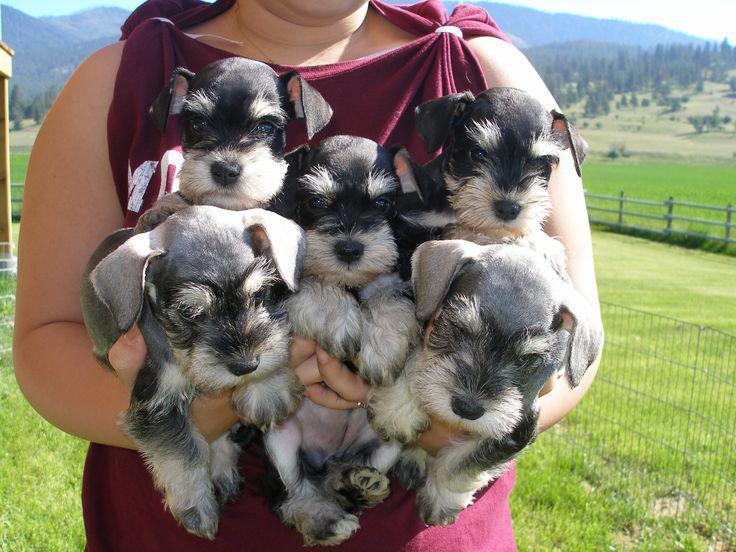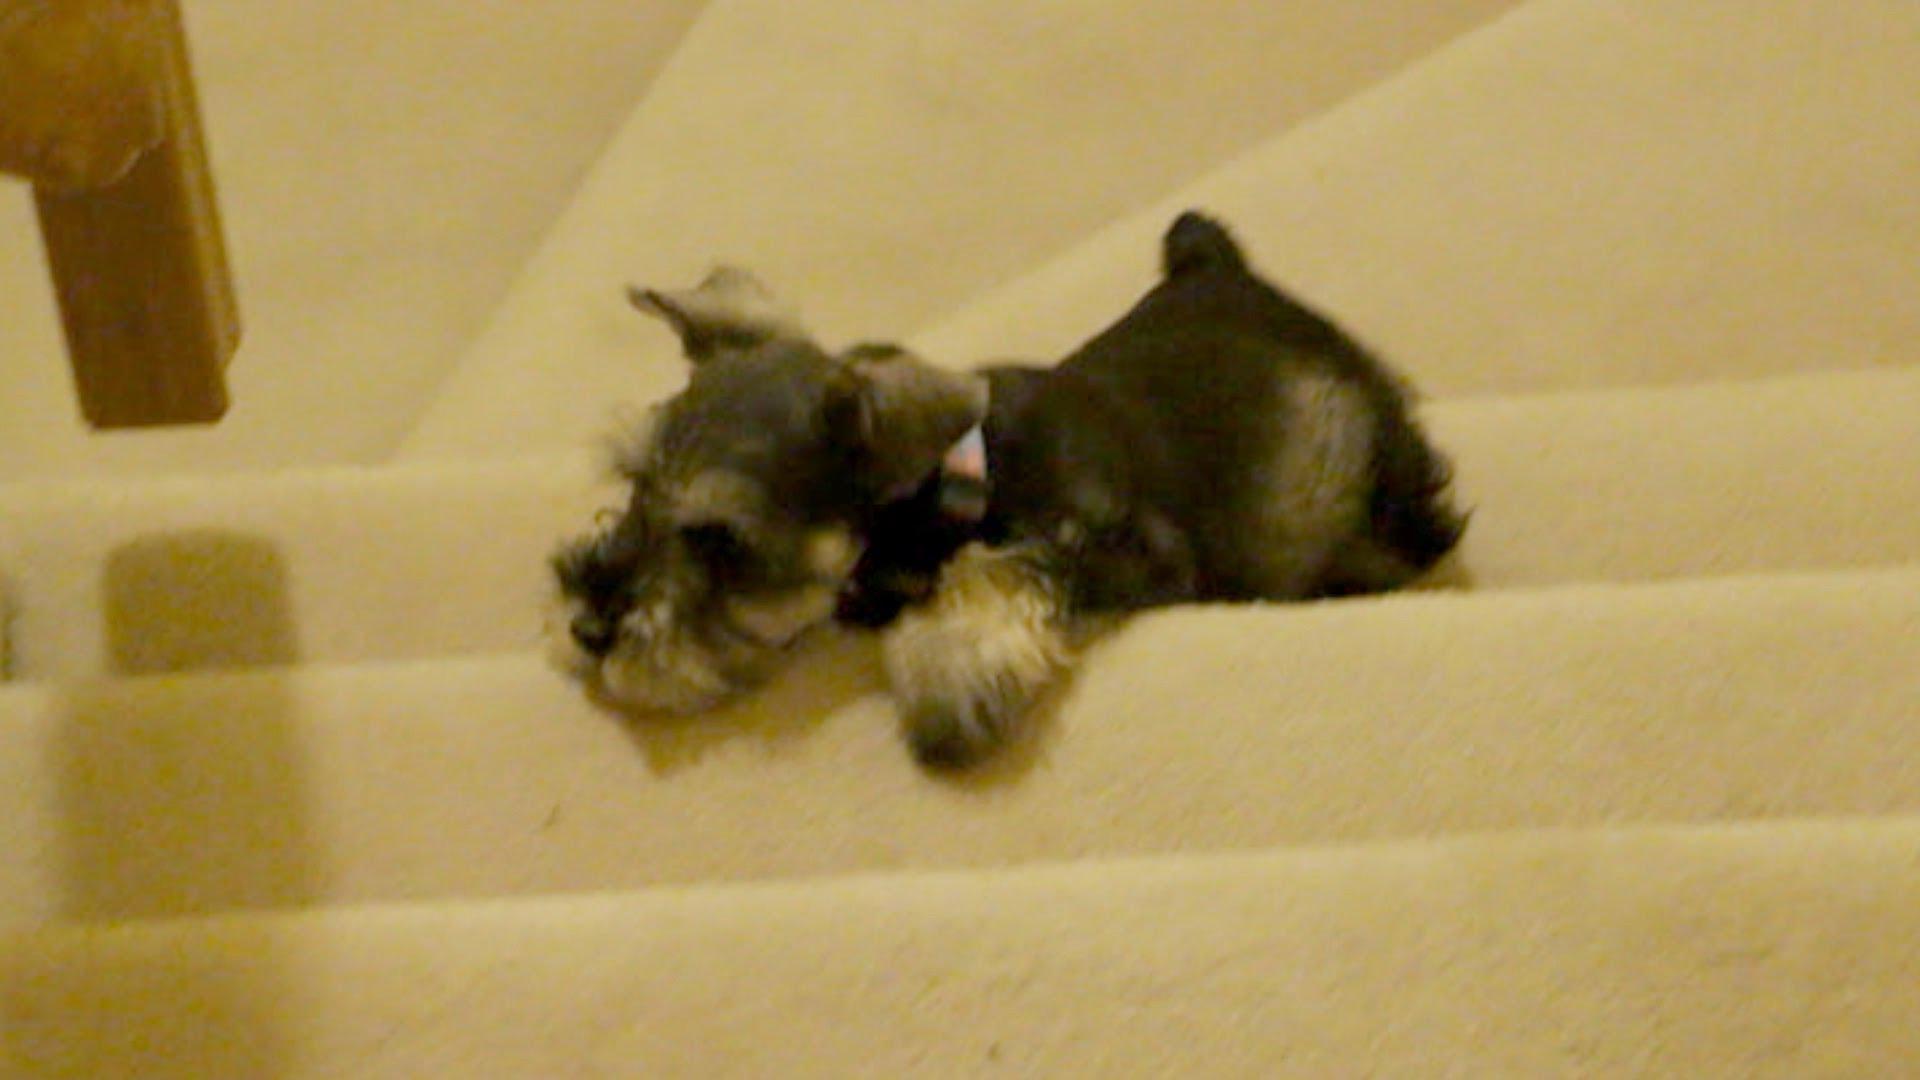The first image is the image on the left, the second image is the image on the right. Assess this claim about the two images: "There are exactly five puppies in one of the images.". Correct or not? Answer yes or no. Yes. 